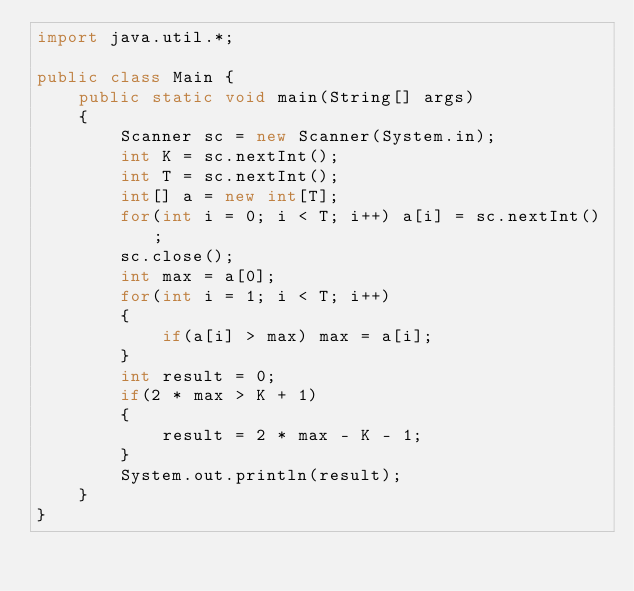Convert code to text. <code><loc_0><loc_0><loc_500><loc_500><_Java_>import java.util.*;

public class Main {
	public static void main(String[] args)
	{
		Scanner sc = new Scanner(System.in);
		int K = sc.nextInt();
		int T = sc.nextInt();
		int[] a = new int[T];
		for(int i = 0; i < T; i++) a[i] = sc.nextInt();
		sc.close();
		int max = a[0];
		for(int i = 1; i < T; i++)
		{
			if(a[i] > max) max = a[i];
		}
		int result = 0;
		if(2 * max > K + 1)
		{
			result = 2 * max - K - 1;
		}
		System.out.println(result);
	}
}</code> 